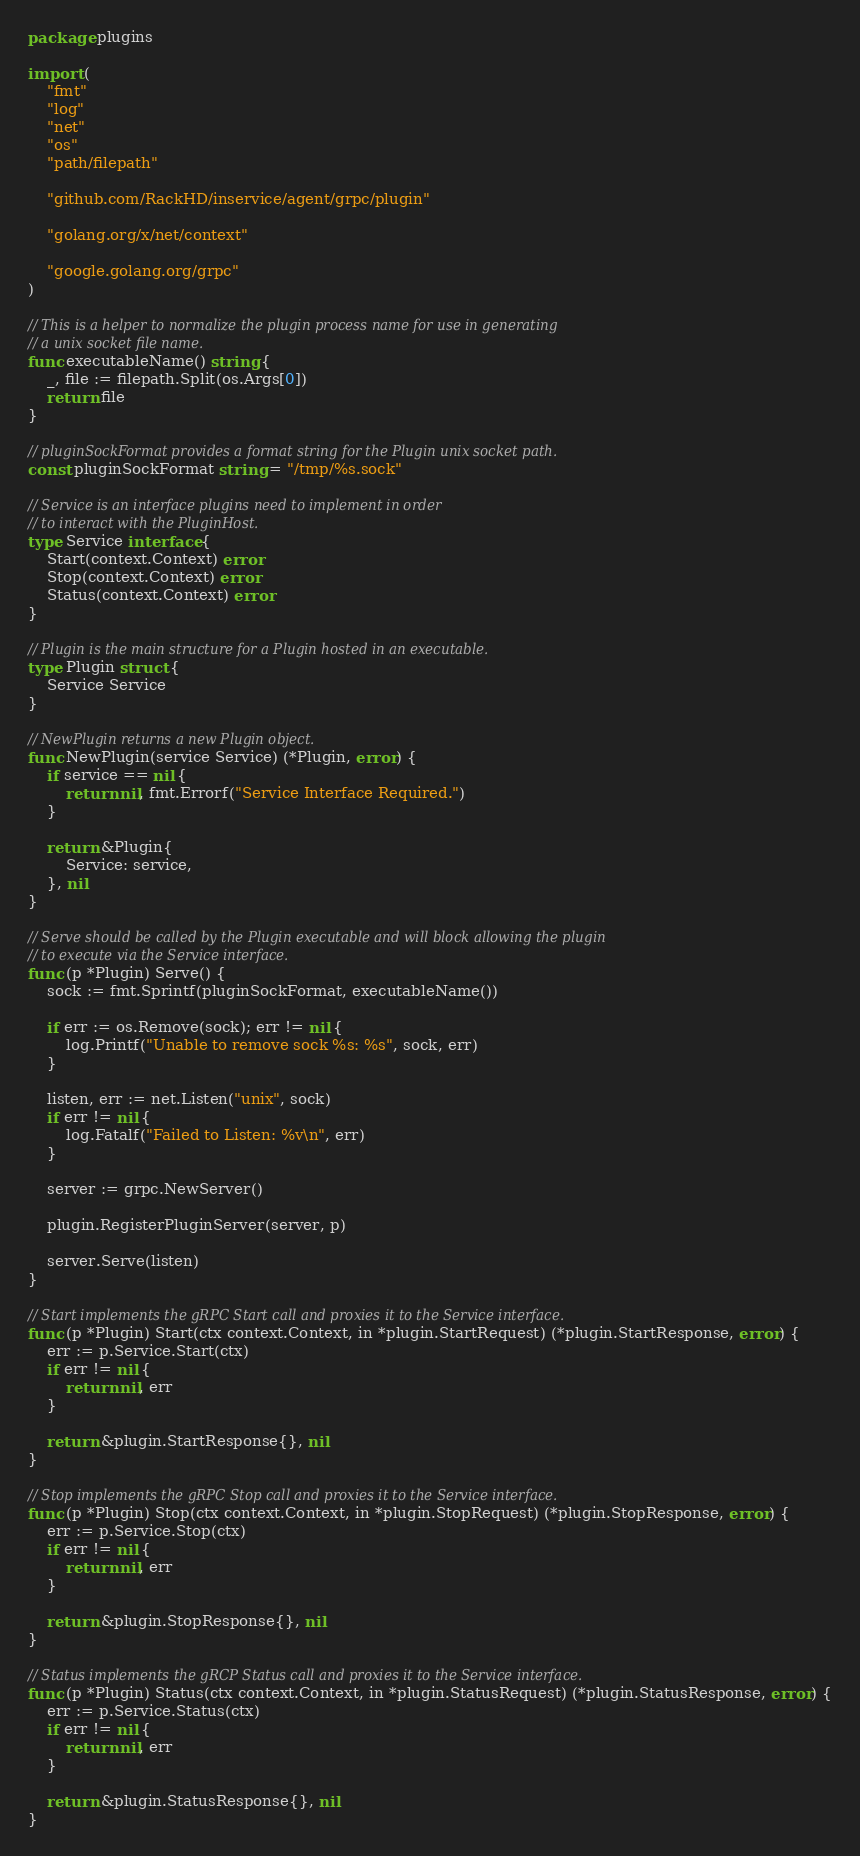<code> <loc_0><loc_0><loc_500><loc_500><_Go_>package plugins

import (
	"fmt"
	"log"
	"net"
	"os"
	"path/filepath"

	"github.com/RackHD/inservice/agent/grpc/plugin"

	"golang.org/x/net/context"

	"google.golang.org/grpc"
)

// This is a helper to normalize the plugin process name for use in generating
// a unix socket file name.
func executableName() string {
	_, file := filepath.Split(os.Args[0])
	return file
}

// pluginSockFormat provides a format string for the Plugin unix socket path.
const pluginSockFormat string = "/tmp/%s.sock"

// Service is an interface plugins need to implement in order
// to interact with the PluginHost.
type Service interface {
	Start(context.Context) error
	Stop(context.Context) error
	Status(context.Context) error
}

// Plugin is the main structure for a Plugin hosted in an executable.
type Plugin struct {
	Service Service
}

// NewPlugin returns a new Plugin object.
func NewPlugin(service Service) (*Plugin, error) {
	if service == nil {
		return nil, fmt.Errorf("Service Interface Required.")
	}

	return &Plugin{
		Service: service,
	}, nil
}

// Serve should be called by the Plugin executable and will block allowing the plugin
// to execute via the Service interface.
func (p *Plugin) Serve() {
	sock := fmt.Sprintf(pluginSockFormat, executableName())

	if err := os.Remove(sock); err != nil {
		log.Printf("Unable to remove sock %s: %s", sock, err)
	}

	listen, err := net.Listen("unix", sock)
	if err != nil {
		log.Fatalf("Failed to Listen: %v\n", err)
	}

	server := grpc.NewServer()

	plugin.RegisterPluginServer(server, p)

	server.Serve(listen)
}

// Start implements the gRPC Start call and proxies it to the Service interface.
func (p *Plugin) Start(ctx context.Context, in *plugin.StartRequest) (*plugin.StartResponse, error) {
	err := p.Service.Start(ctx)
	if err != nil {
		return nil, err
	}

	return &plugin.StartResponse{}, nil
}

// Stop implements the gRPC Stop call and proxies it to the Service interface.
func (p *Plugin) Stop(ctx context.Context, in *plugin.StopRequest) (*plugin.StopResponse, error) {
	err := p.Service.Stop(ctx)
	if err != nil {
		return nil, err
	}

	return &plugin.StopResponse{}, nil
}

// Status implements the gRCP Status call and proxies it to the Service interface.
func (p *Plugin) Status(ctx context.Context, in *plugin.StatusRequest) (*plugin.StatusResponse, error) {
	err := p.Service.Status(ctx)
	if err != nil {
		return nil, err
	}

	return &plugin.StatusResponse{}, nil
}
</code> 